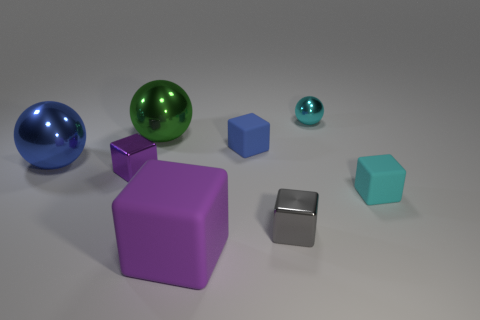There is a object that is the same color as the large rubber block; what material is it?
Your answer should be very brief. Metal. What number of other objects are the same color as the large cube?
Give a very brief answer. 1. There is a shiny block on the left side of the purple matte block; how many tiny gray metal blocks are to the left of it?
Ensure brevity in your answer.  0. There is a small cyan metal object; are there any tiny blue cubes right of it?
Give a very brief answer. No. What is the shape of the blue object on the right side of the matte thing left of the blue matte cube?
Offer a very short reply. Cube. Is the number of large blue objects that are on the right side of the gray object less than the number of cyan matte blocks that are in front of the blue rubber block?
Your answer should be very brief. Yes. The big object that is the same shape as the tiny blue object is what color?
Make the answer very short. Purple. What number of small metal things are behind the blue cube and in front of the tiny sphere?
Your response must be concise. 0. Are there more blocks that are behind the gray cube than small things in front of the green shiny sphere?
Offer a terse response. No. What size is the blue metal thing?
Give a very brief answer. Large. 